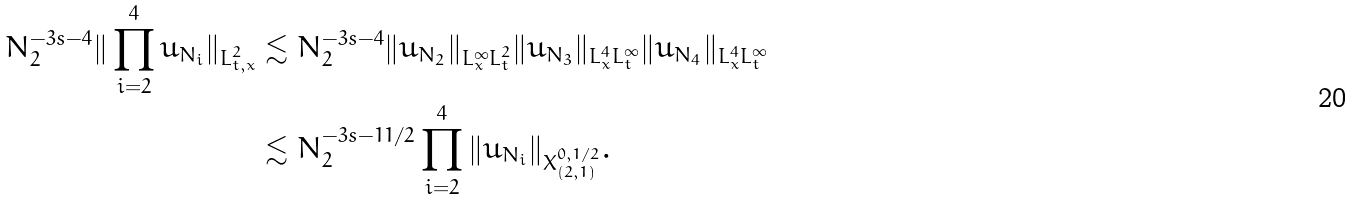<formula> <loc_0><loc_0><loc_500><loc_500>N _ { 2 } ^ { - 3 s - 4 } \| \prod _ { i = 2 } ^ { 4 } u _ { N _ { i } } \| _ { L _ { t , x } ^ { 2 } } & \lesssim N _ { 2 } ^ { - 3 s - 4 } \| u _ { N _ { 2 } } \| _ { L _ { x } ^ { \infty } L _ { t } ^ { 2 } } \| u _ { N _ { 3 } } \| _ { L _ { x } ^ { 4 } L _ { t } ^ { \infty } } \| u _ { N _ { 4 } } \| _ { L _ { x } ^ { 4 } L _ { t } ^ { \infty } } \\ & \lesssim N _ { 2 } ^ { - 3 s - 1 1 / 2 } \prod _ { i = 2 } ^ { 4 } \| u _ { N _ { i } } \| _ { X _ { ( 2 , 1 ) } ^ { 0 , 1 / 2 } } .</formula> 